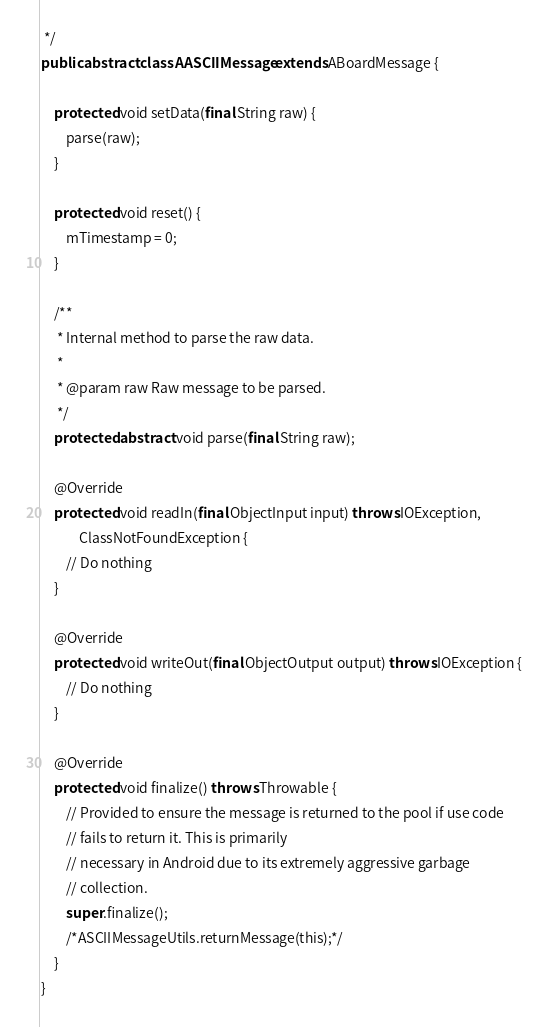Convert code to text. <code><loc_0><loc_0><loc_500><loc_500><_Java_> */
public abstract class AASCIIMessage extends ABoardMessage {

    protected void setData(final String raw) {
        parse(raw);
    }

    protected void reset() {
        mTimestamp = 0;
    }

    /**
     * Internal method to parse the raw data.
     *
     * @param raw Raw message to be parsed.
     */
    protected abstract void parse(final String raw);

    @Override
    protected void readIn(final ObjectInput input) throws IOException,
            ClassNotFoundException {
        // Do nothing
    }

    @Override
    protected void writeOut(final ObjectOutput output) throws IOException {
        // Do nothing
    }

    @Override
    protected void finalize() throws Throwable {
        // Provided to ensure the message is returned to the pool if use code
        // fails to return it. This is primarily
        // necessary in Android due to its extremely aggressive garbage
        // collection.
        super.finalize();
        /*ASCIIMessageUtils.returnMessage(this);*/
    }
}
</code> 